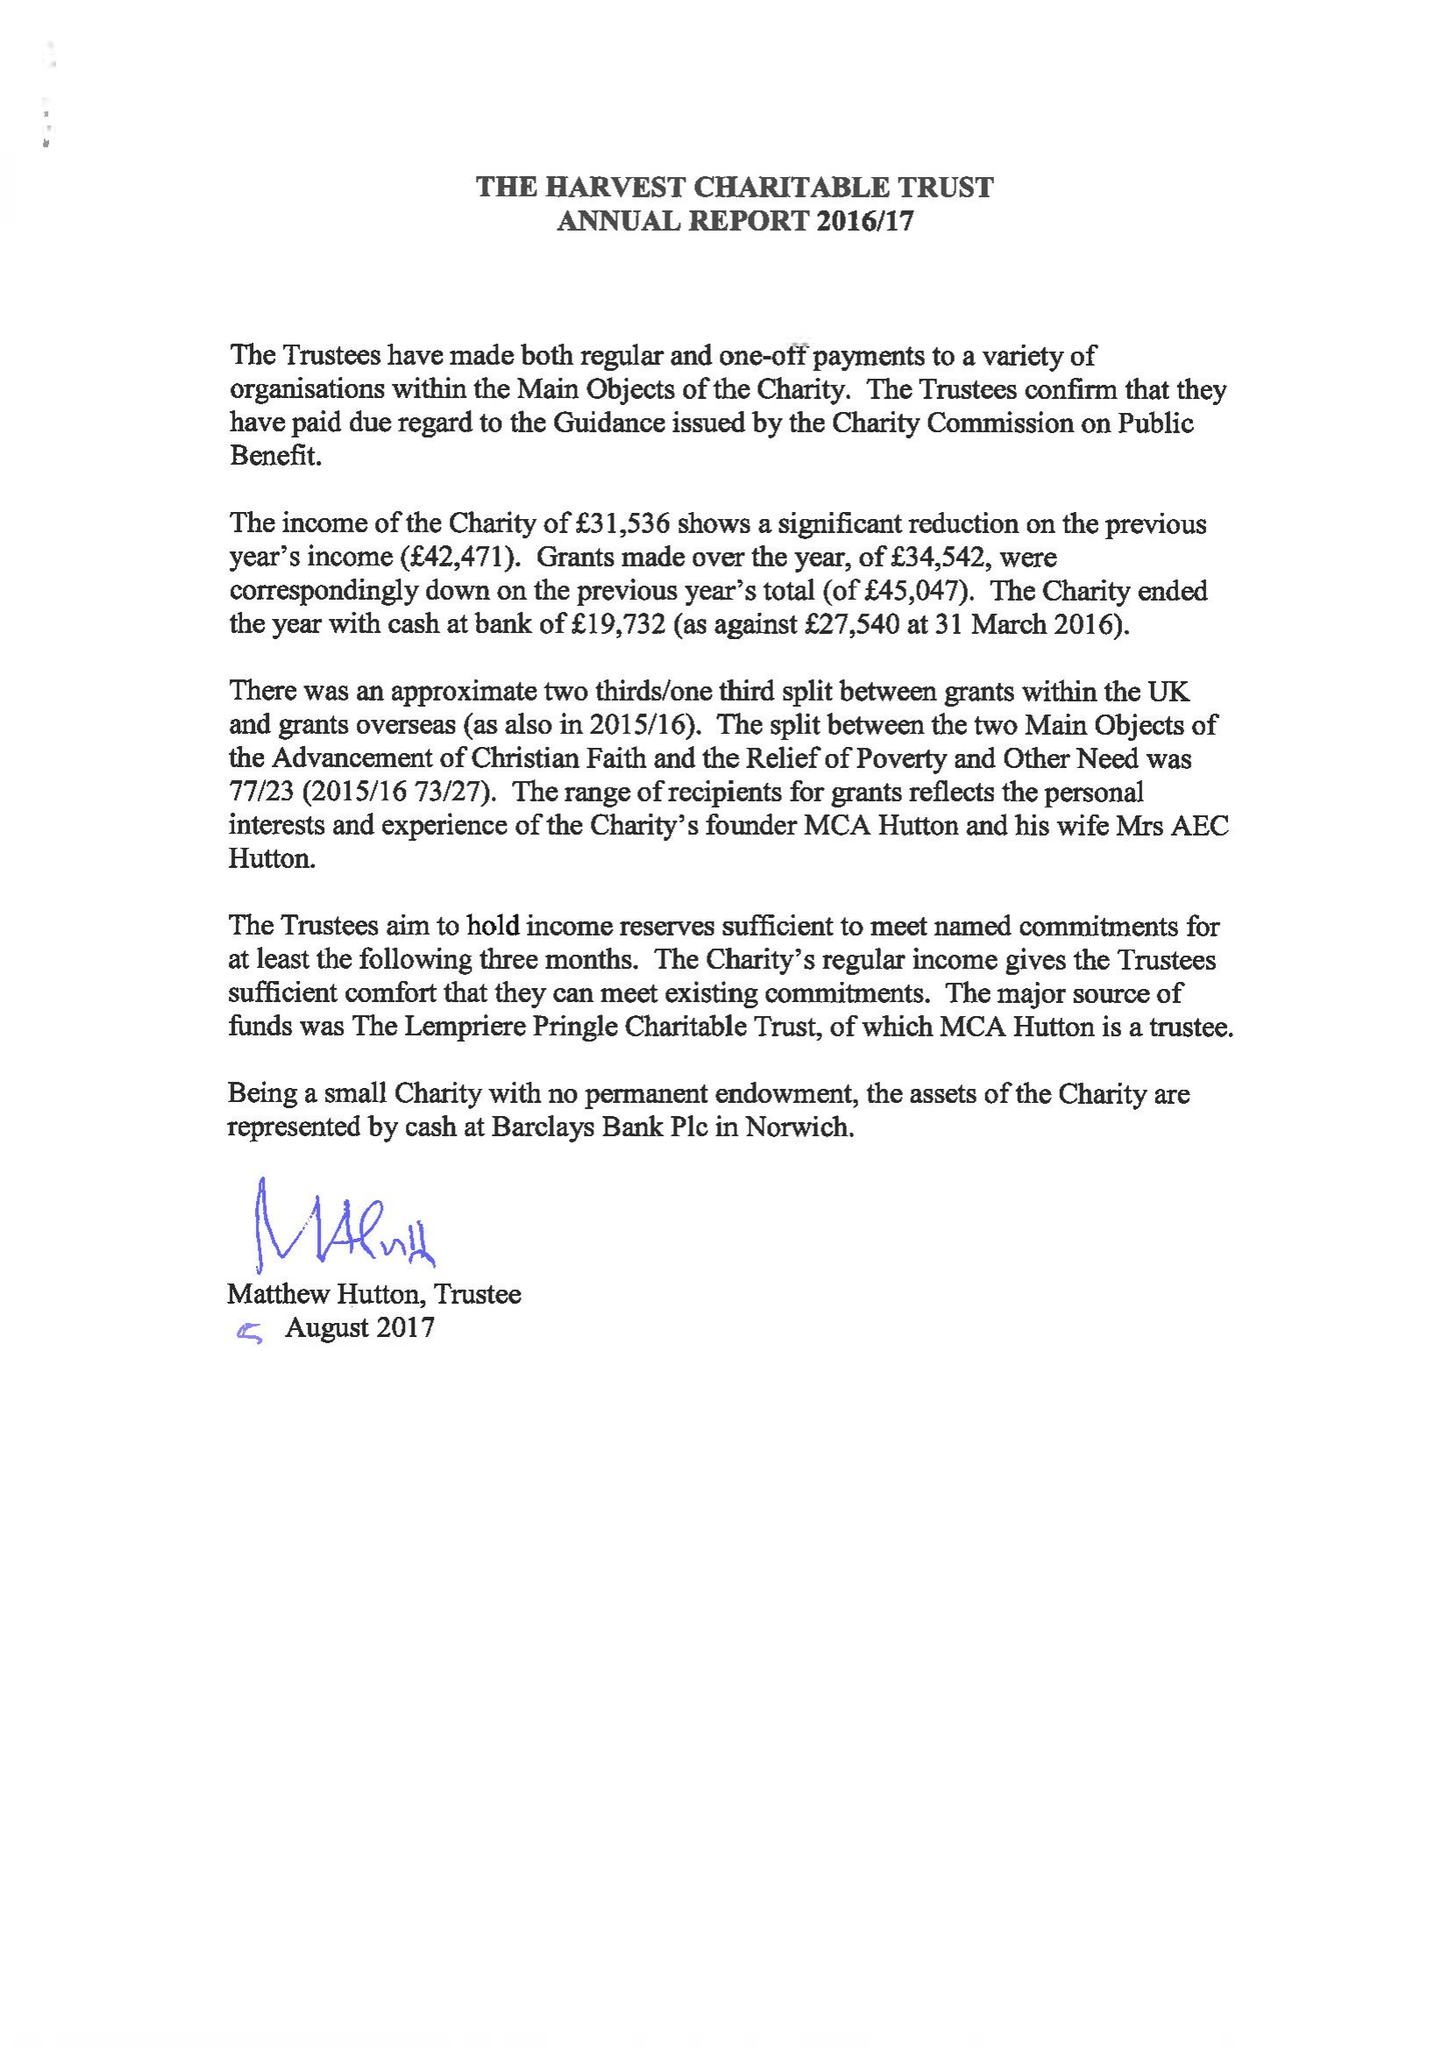What is the value for the charity_number?
Answer the question using a single word or phrase. 326159 